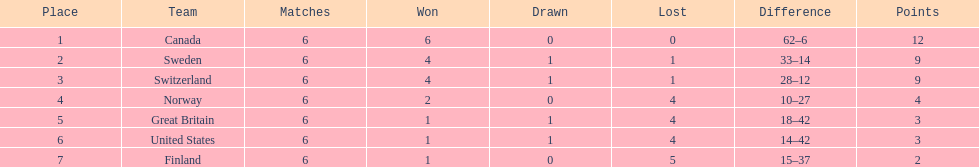Who had a stronger performance in the 1951 world ice hockey championships, switzerland or great britain? Switzerland. 